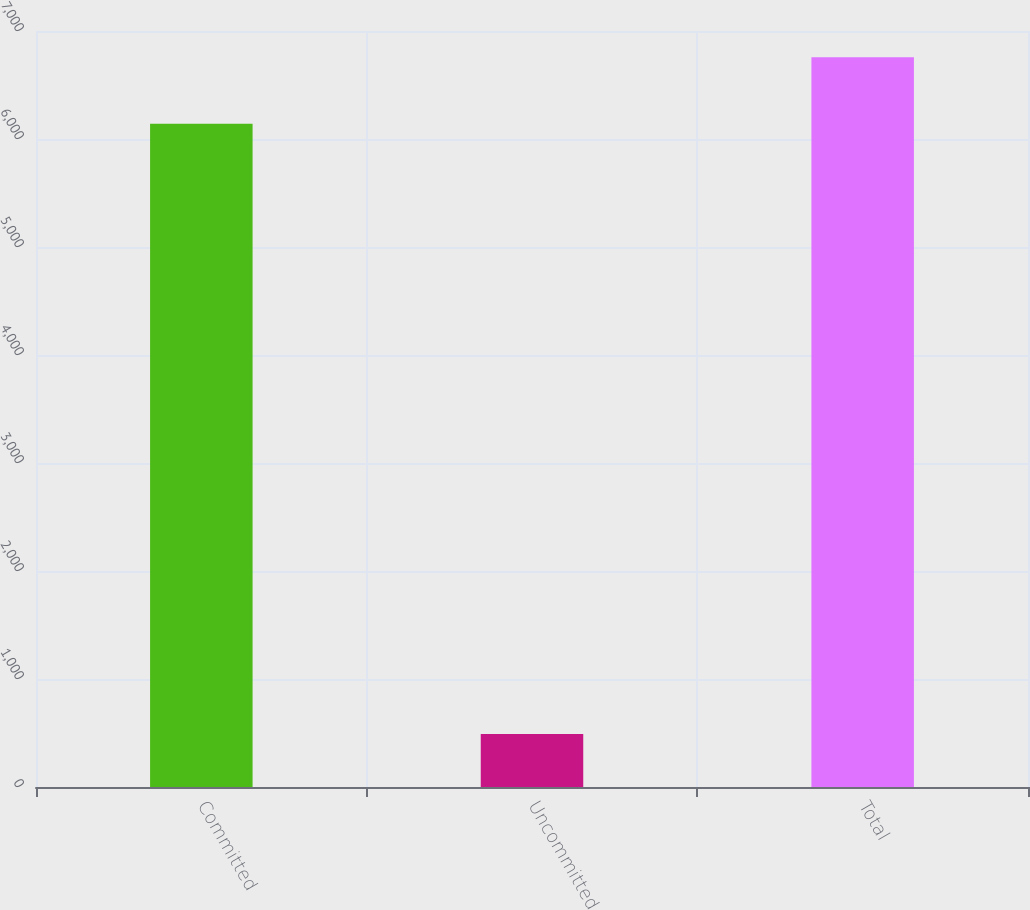<chart> <loc_0><loc_0><loc_500><loc_500><bar_chart><fcel>Committed<fcel>Uncommitted<fcel>Total<nl><fcel>6142<fcel>490<fcel>6756.2<nl></chart> 